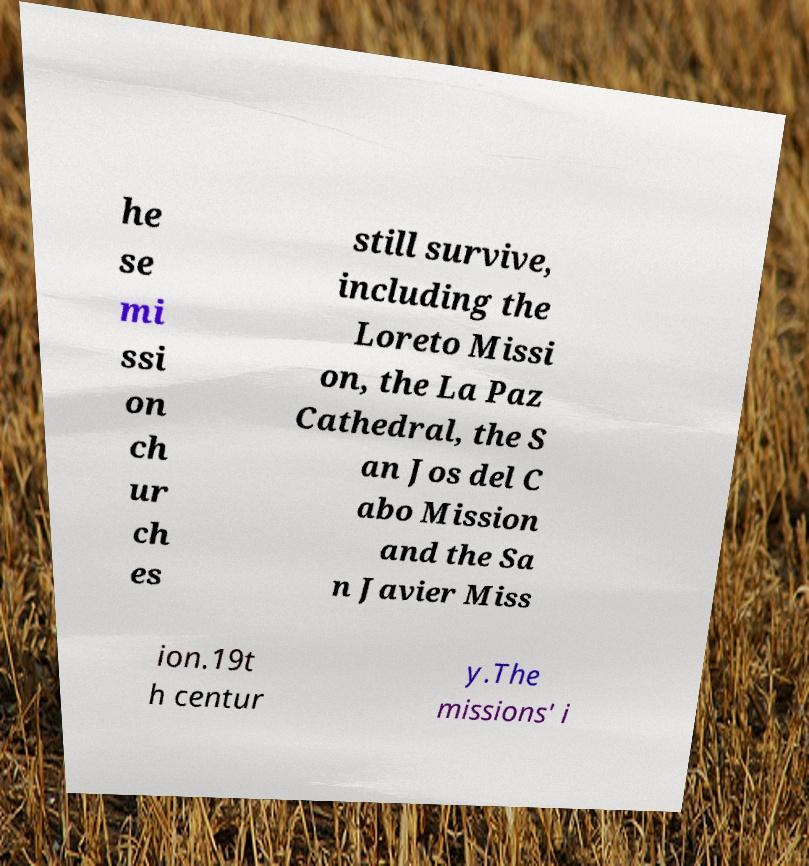Can you accurately transcribe the text from the provided image for me? he se mi ssi on ch ur ch es still survive, including the Loreto Missi on, the La Paz Cathedral, the S an Jos del C abo Mission and the Sa n Javier Miss ion.19t h centur y.The missions' i 